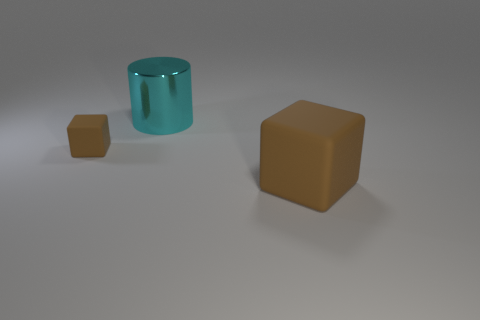The thing that is both behind the large matte object and in front of the large cyan object is made of what material? The object you're referring to appears to be a smaller cube behind the larger matte-finished cube and in front of the large cyan cylinder. Its surface has a specular highlight suggesting that it is made of a material with a smooth and possibly shiny texture, similar to plastic. 